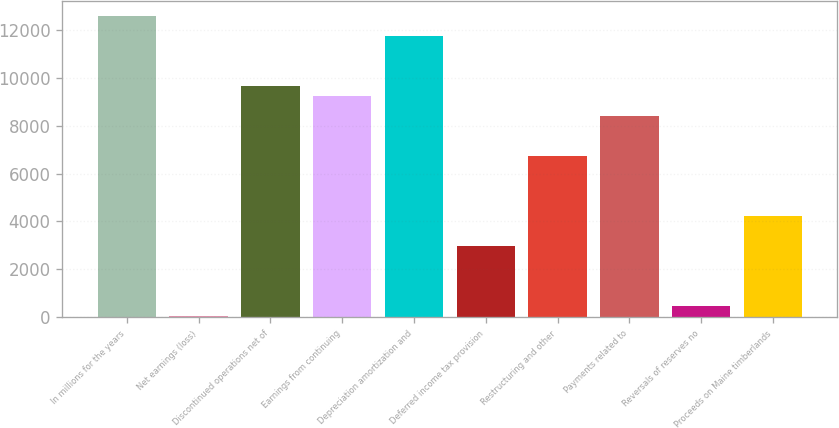Convert chart. <chart><loc_0><loc_0><loc_500><loc_500><bar_chart><fcel>In millions for the years<fcel>Net earnings (loss)<fcel>Discontinued operations net of<fcel>Earnings from continuing<fcel>Depreciation amortization and<fcel>Deferred income tax provision<fcel>Restructuring and other<fcel>Payments related to<fcel>Reversals of reserves no<fcel>Proceeds on Maine timberlands<nl><fcel>12581<fcel>35<fcel>9653.6<fcel>9235.4<fcel>11744.6<fcel>2962.4<fcel>6726.2<fcel>8399<fcel>453.2<fcel>4217<nl></chart> 